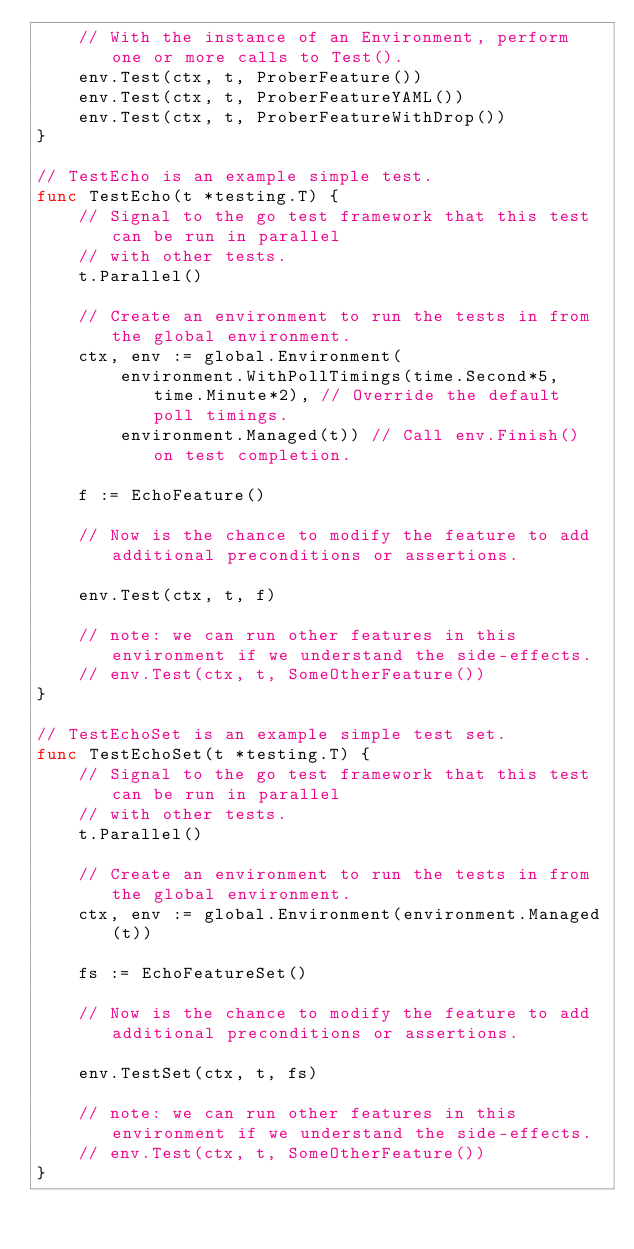<code> <loc_0><loc_0><loc_500><loc_500><_Go_>	// With the instance of an Environment, perform one or more calls to Test().
	env.Test(ctx, t, ProberFeature())
	env.Test(ctx, t, ProberFeatureYAML())
	env.Test(ctx, t, ProberFeatureWithDrop())
}

// TestEcho is an example simple test.
func TestEcho(t *testing.T) {
	// Signal to the go test framework that this test can be run in parallel
	// with other tests.
	t.Parallel()

	// Create an environment to run the tests in from the global environment.
	ctx, env := global.Environment(
		environment.WithPollTimings(time.Second*5, time.Minute*2), // Override the default poll timings.
		environment.Managed(t)) // Call env.Finish() on test completion.

	f := EchoFeature()

	// Now is the chance to modify the feature to add additional preconditions or assertions.

	env.Test(ctx, t, f)

	// note: we can run other features in this environment if we understand the side-effects.
	// env.Test(ctx, t, SomeOtherFeature())
}

// TestEchoSet is an example simple test set.
func TestEchoSet(t *testing.T) {
	// Signal to the go test framework that this test can be run in parallel
	// with other tests.
	t.Parallel()

	// Create an environment to run the tests in from the global environment.
	ctx, env := global.Environment(environment.Managed(t))

	fs := EchoFeatureSet()

	// Now is the chance to modify the feature to add additional preconditions or assertions.

	env.TestSet(ctx, t, fs)

	// note: we can run other features in this environment if we understand the side-effects.
	// env.Test(ctx, t, SomeOtherFeature())
}
</code> 